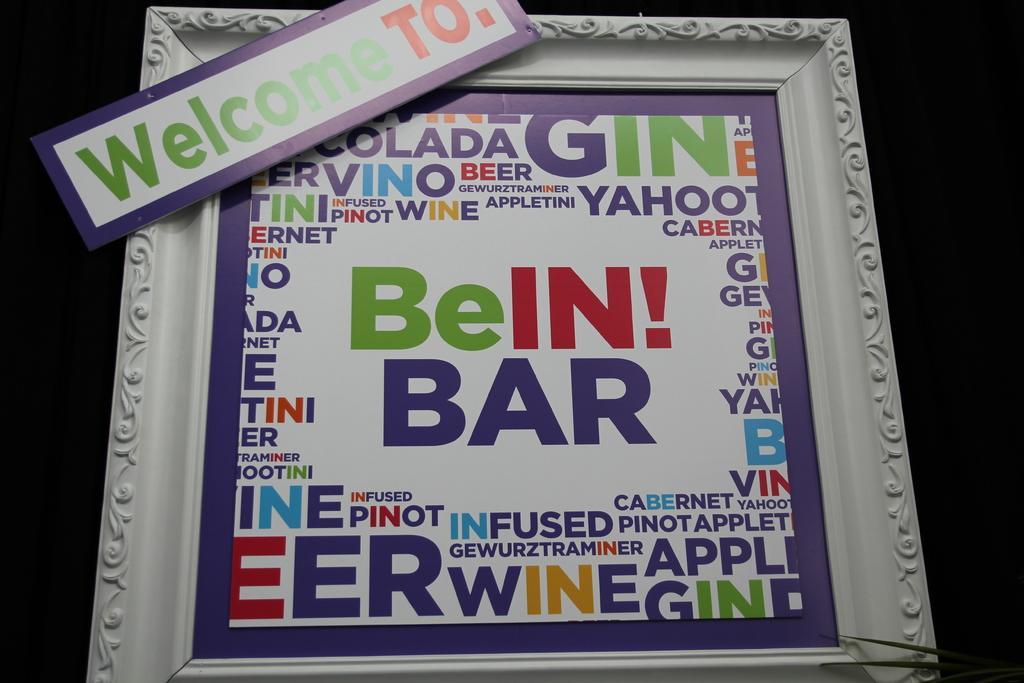<image>
Give a short and clear explanation of the subsequent image. Picture frame with the words "BeIN! Bar" in the middle. 